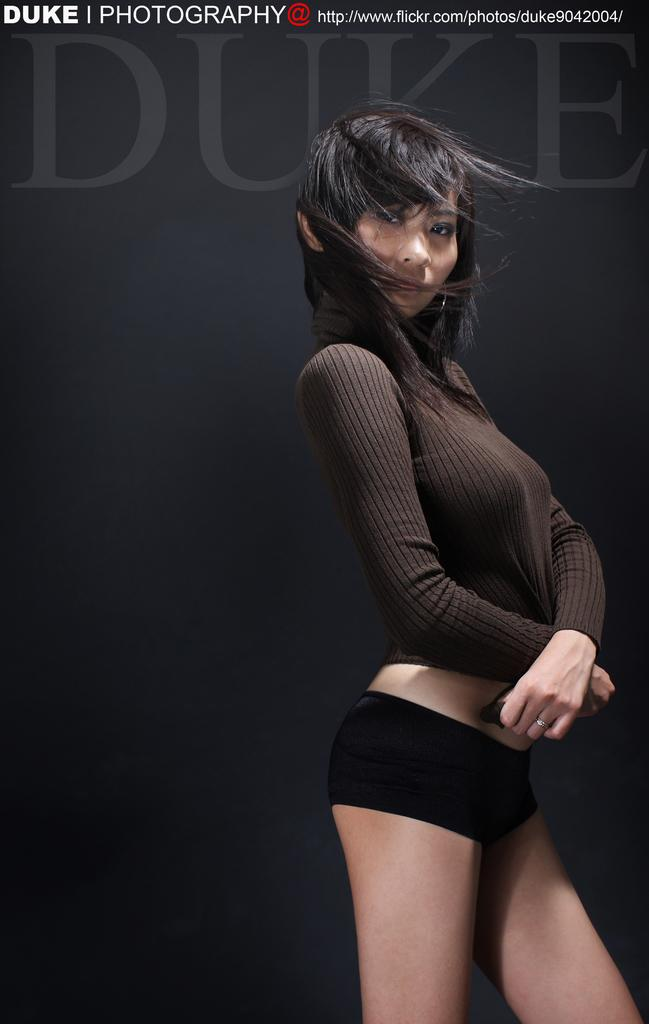What is the main subject of the image? There is a beautiful lady in the image. What is the lady doing in the image? The lady is standing. What color is the T-shirt the lady is wearing? The lady is wearing a black color T-shirt. What color are the shorts the lady is wearing? The lady is wearing black color shorts. What language is the lady speaking in the image? There is no indication of the language being spoken in the image. Is there a mailbox visible in the image? There is no mention of a mailbox in the provided facts, so it cannot be determined if one is present in the image. 